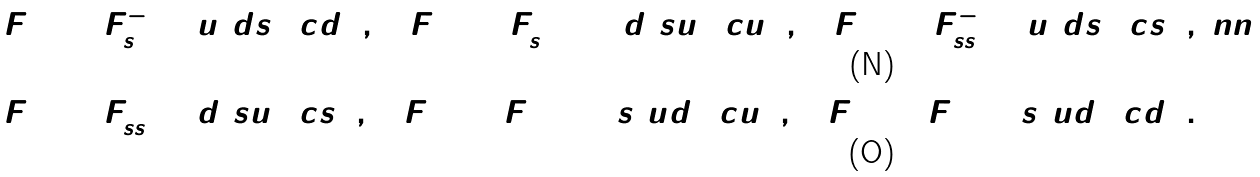Convert formula to latex. <formula><loc_0><loc_0><loc_500><loc_500>F _ { 2 } ^ { 1 1 } & = F _ { s } ^ { - } = \bar { u } ( d s ) ( c d ) \, , \quad F _ { 1 } ^ { 2 2 } = F _ { s } ^ { + + } = \bar { d } ( s u ) ( c u ) \, , \quad F _ { 3 } ^ { 1 1 } = F _ { s s } ^ { - } = \bar { u } ( d s ) ( c s ) \, , \ n n \\ F _ { 3 } ^ { 2 2 } & = F _ { s s } ^ { + } = \bar { d } ( s u ) ( c s ) \, , \quad F _ { 1 } ^ { 3 3 } = F ^ { + + } = \bar { s } ( u d ) ( c u ) \, , \quad F _ { 2 } ^ { 3 3 } = F ^ { + } = \bar { s } ( u d ) ( c d ) \, .</formula> 